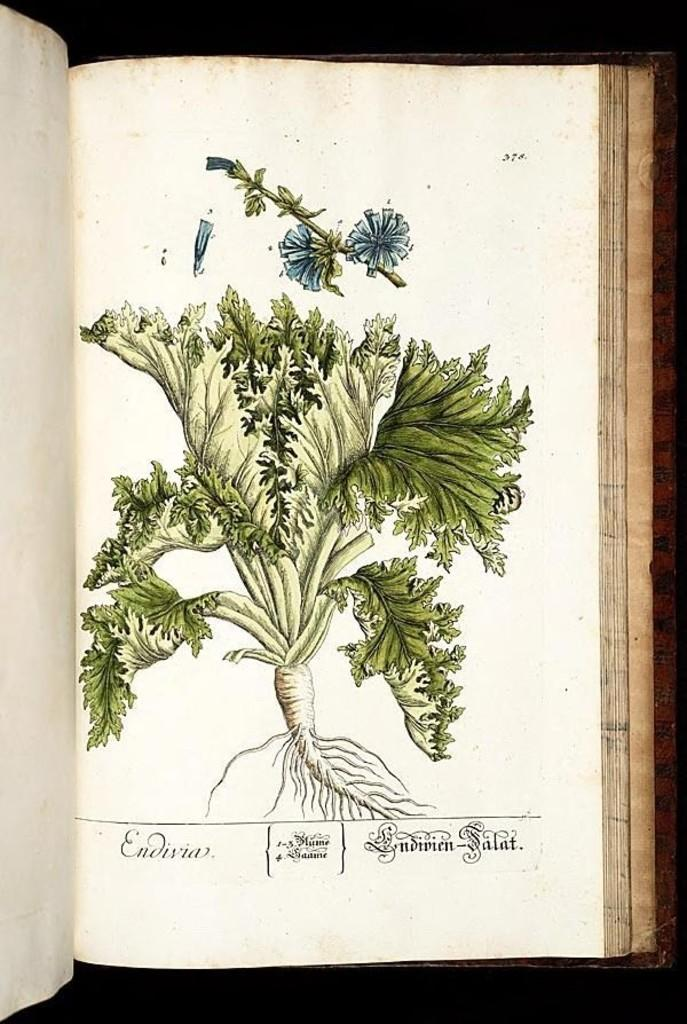What is the person holding in the image? The person is holding a phone. What object is present on the table in the image? There is a laptop on the table. Can you describe the wilderness surrounding the person in the image? There is no wilderness present in the image; it features a person holding a phone and a laptop on a table. Is there a stranger in the image? The image does not depict a stranger; it only shows a person holding a phone and a laptop on a table. 